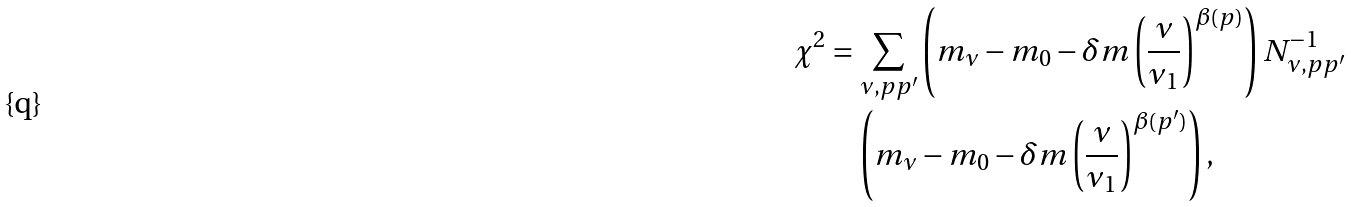Convert formula to latex. <formula><loc_0><loc_0><loc_500><loc_500>\chi ^ { 2 } & = \sum _ { \nu , p p ^ { \prime } } \left ( m _ { \nu } - m _ { 0 } - \delta m \left ( \frac { \nu } { \nu _ { 1 } } \right ) ^ { \beta ( p ) } \right ) N _ { \nu , p p ^ { \prime } } ^ { - 1 } \\ & \quad \left ( m _ { \nu } - m _ { 0 } - \delta m \left ( \frac { \nu } { \nu _ { 1 } } \right ) ^ { \beta ( p ^ { \prime } ) } \right ) ,</formula> 